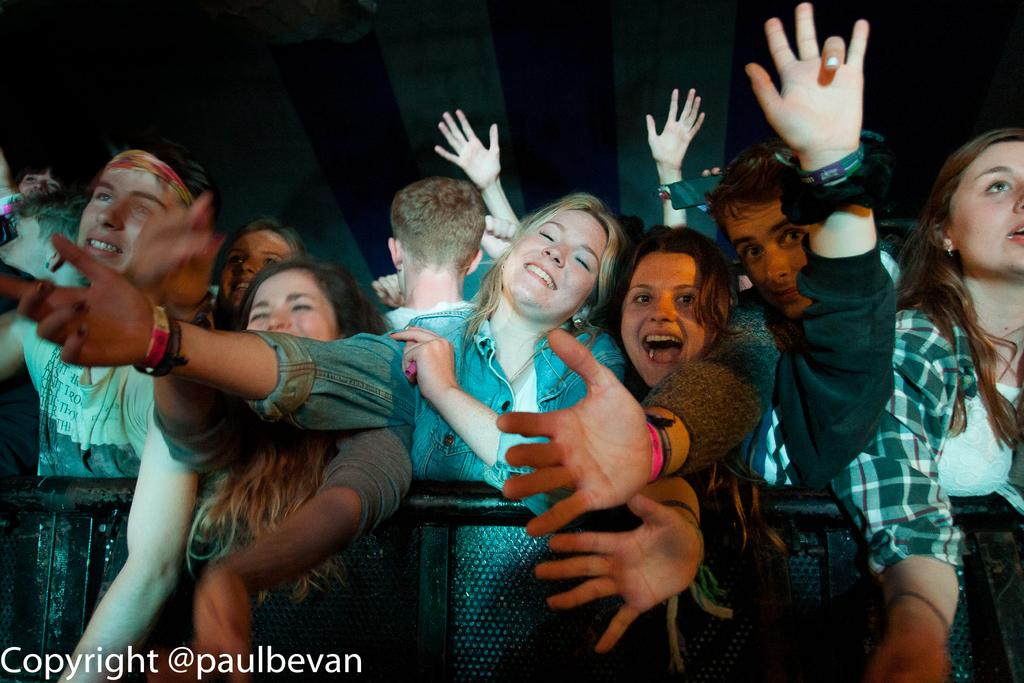What is happening in the image? There are people standing in the image. What can be seen in the background of the image? The background of the image is dark. What type of barrier is present in the image? There is a metal fence in the image. Where is the text located in the image? The text is at the bottom left corner of the image. What type of vegetable is hanging from the metal fence in the image? There are no vegetables present in the image, and nothing is hanging from the metal fence. 